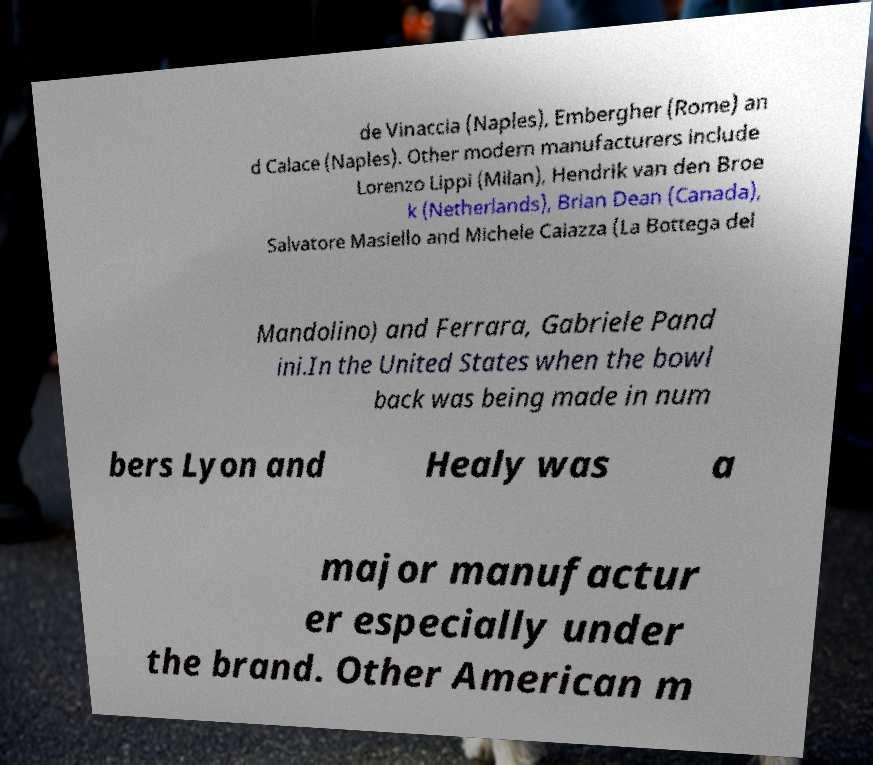What messages or text are displayed in this image? I need them in a readable, typed format. de Vinaccia (Naples), Embergher (Rome) an d Calace (Naples). Other modern manufacturers include Lorenzo Lippi (Milan), Hendrik van den Broe k (Netherlands), Brian Dean (Canada), Salvatore Masiello and Michele Caiazza (La Bottega del Mandolino) and Ferrara, Gabriele Pand ini.In the United States when the bowl back was being made in num bers Lyon and Healy was a major manufactur er especially under the brand. Other American m 